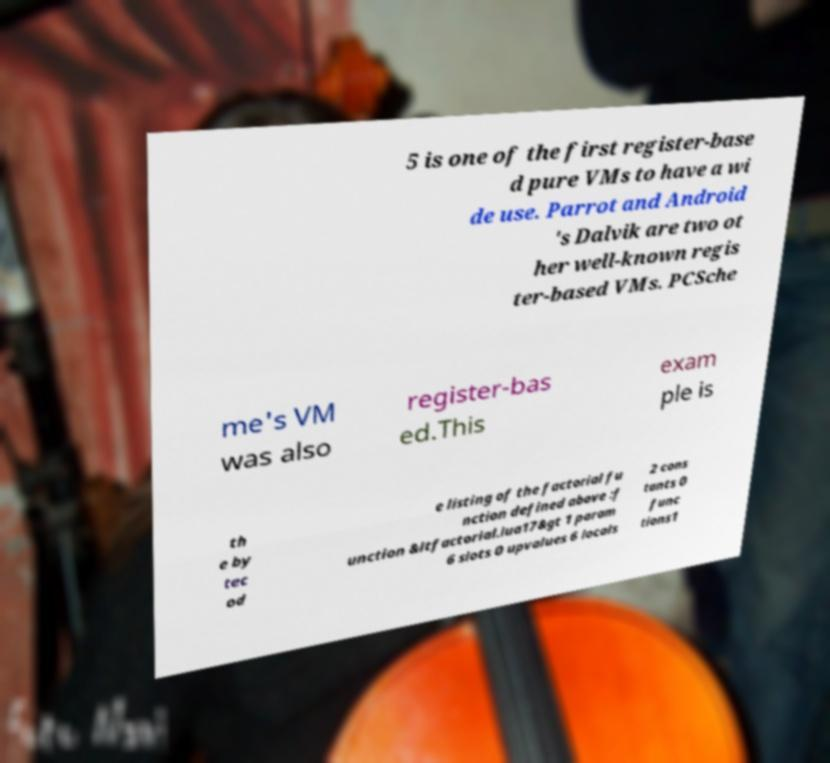Please identify and transcribe the text found in this image. 5 is one of the first register-base d pure VMs to have a wi de use. Parrot and Android 's Dalvik are two ot her well-known regis ter-based VMs. PCSche me's VM was also register-bas ed.This exam ple is th e by tec od e listing of the factorial fu nction defined above :f unction &ltfactorial.lua17&gt 1 param 6 slots 0 upvalues 6 locals 2 cons tants 0 func tions1 